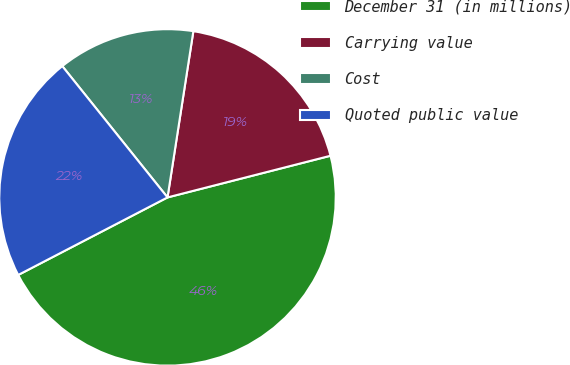<chart> <loc_0><loc_0><loc_500><loc_500><pie_chart><fcel>December 31 (in millions)<fcel>Carrying value<fcel>Cost<fcel>Quoted public value<nl><fcel>46.36%<fcel>18.56%<fcel>13.21%<fcel>21.87%<nl></chart> 